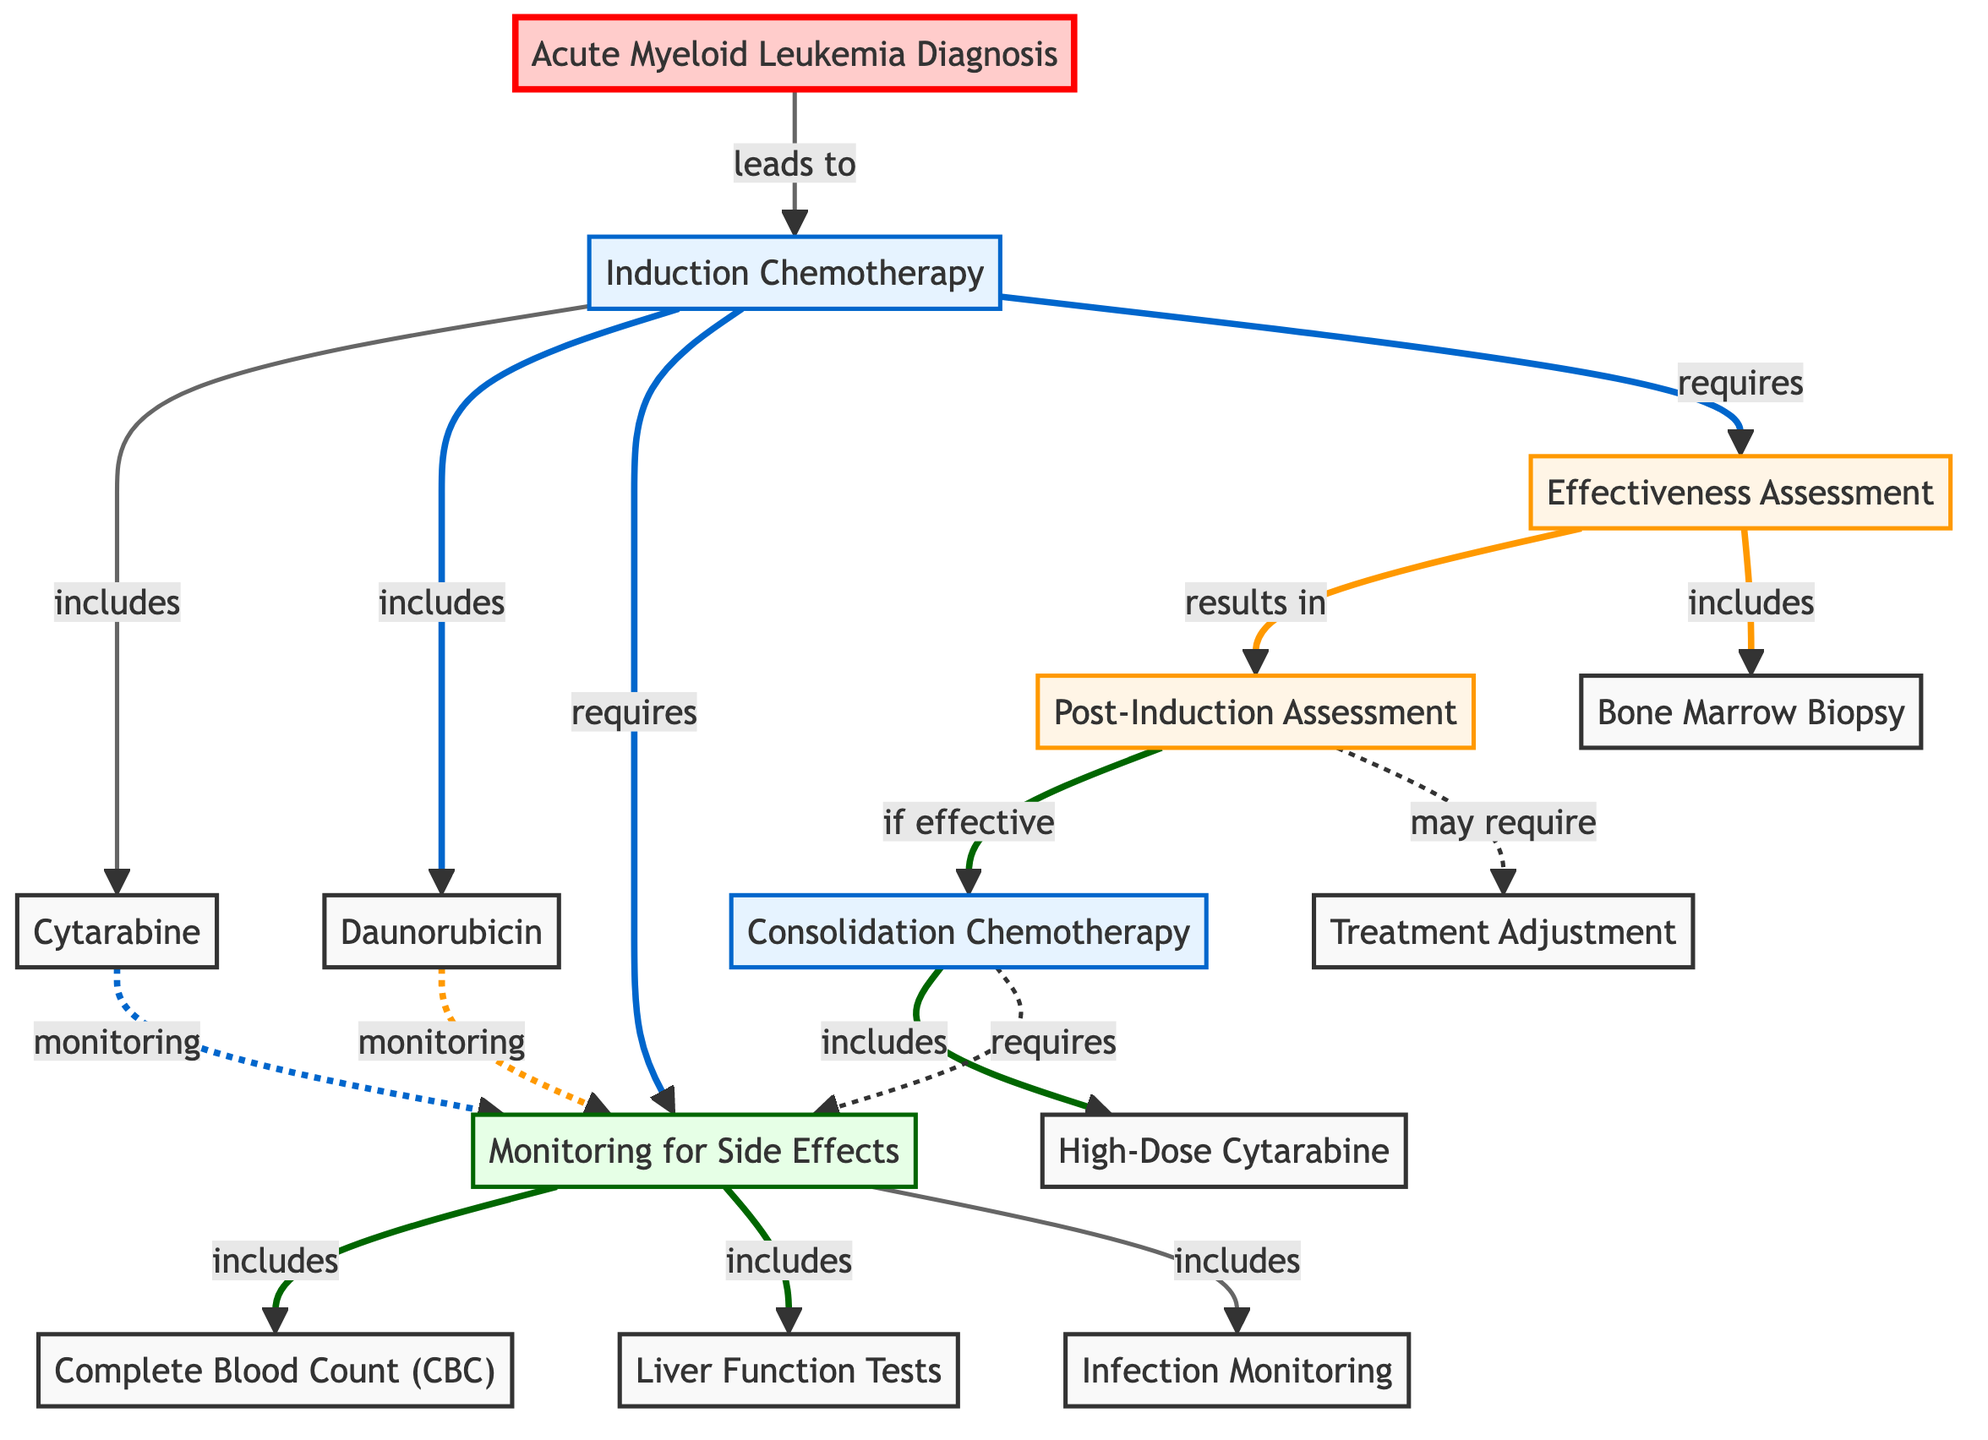What is the starting point of the treatment process? The treatment process begins with the "Acute Myeloid Leukemia Diagnosis" node, as indicated by the arrow leading from it to "Induction Chemotherapy."
Answer: Acute Myeloid Leukemia Diagnosis How many chemotherapy medications are included in the Induction Chemotherapy? The "Induction Chemotherapy" node points to two chemotherapy medications - "Cytarabine" and "Daunorubicin," indicating it includes both.
Answer: 2 What type of assessment follows the Effectiveness Assessment? The "Effectiveness Assessment" leads to the "Post-Induction Assessment," showing that this assessment follows.
Answer: Post-Induction Assessment What tests are included in Monitoring for Side Effects? The "Monitoring for Side Effects" node includes "Complete Blood Count (CBC)," "Liver Function Tests," and "Infection Monitoring," indicating these tests are part of side effect monitoring.
Answer: Complete Blood Count (CBC), Liver Function Tests, Infection Monitoring What happens if the Post-Induction Assessment is effective? If the Post-Induction Assessment is effective, it leads to "Consolidation Chemotherapy," indicating a successful outcome of the initial treatment phase.
Answer: Consolidation Chemotherapy Which medications are part of the Consolidation Chemotherapy? The "Consolidation Chemotherapy" node includes "High-Dose Cytarabine," representing the specific medication used in this phase.
Answer: High-Dose Cytarabine What does monitoring for side effects require? The Induction Chemotherapy requires monitoring for side effects, involving various tests to track the patient's response to treatment.
Answer: Monitoring for Side Effects How many nodes are related to the Induction Chemotherapy process? The nodes directly related to the Induction Chemotherapy are "Cytarabine," "Daunorubicin," "Monitoring for Side Effects," and "Effectiveness Assessment," totaling four nodes.
Answer: 4 What type of biopsy may be performed after Effectiveness Assessment? A "Bone Marrow Biopsy" is included in the Effectiveness Assessment, indicating this procedure may be performed during this stage.
Answer: Bone Marrow Biopsy 